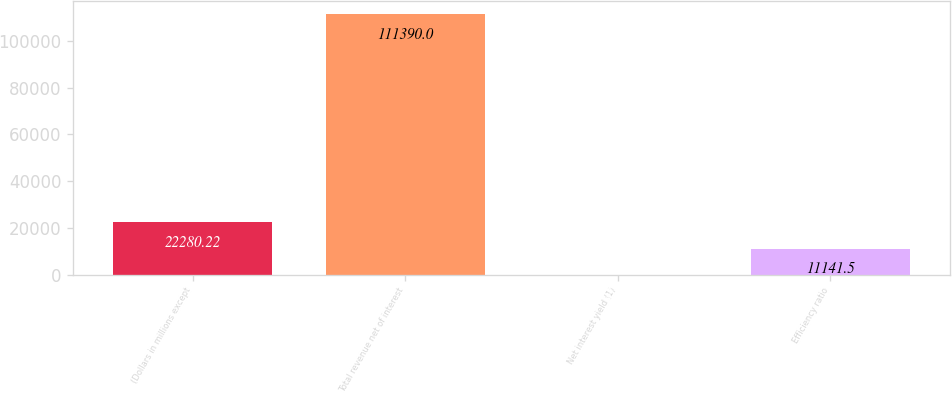Convert chart to OTSL. <chart><loc_0><loc_0><loc_500><loc_500><bar_chart><fcel>(Dollars in millions except<fcel>Total revenue net of interest<fcel>Net interest yield (1)<fcel>Efficiency ratio<nl><fcel>22280.2<fcel>111390<fcel>2.78<fcel>11141.5<nl></chart> 